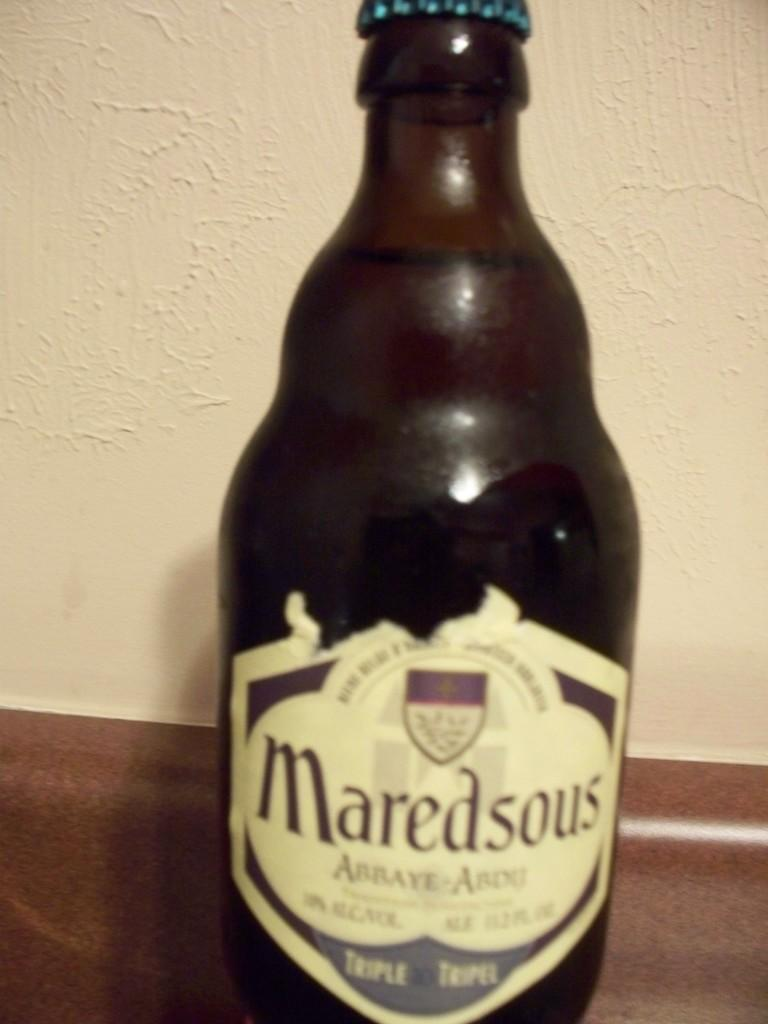<image>
Write a terse but informative summary of the picture. A dark brown bottle of alcohol called Maredsous sits alone. 